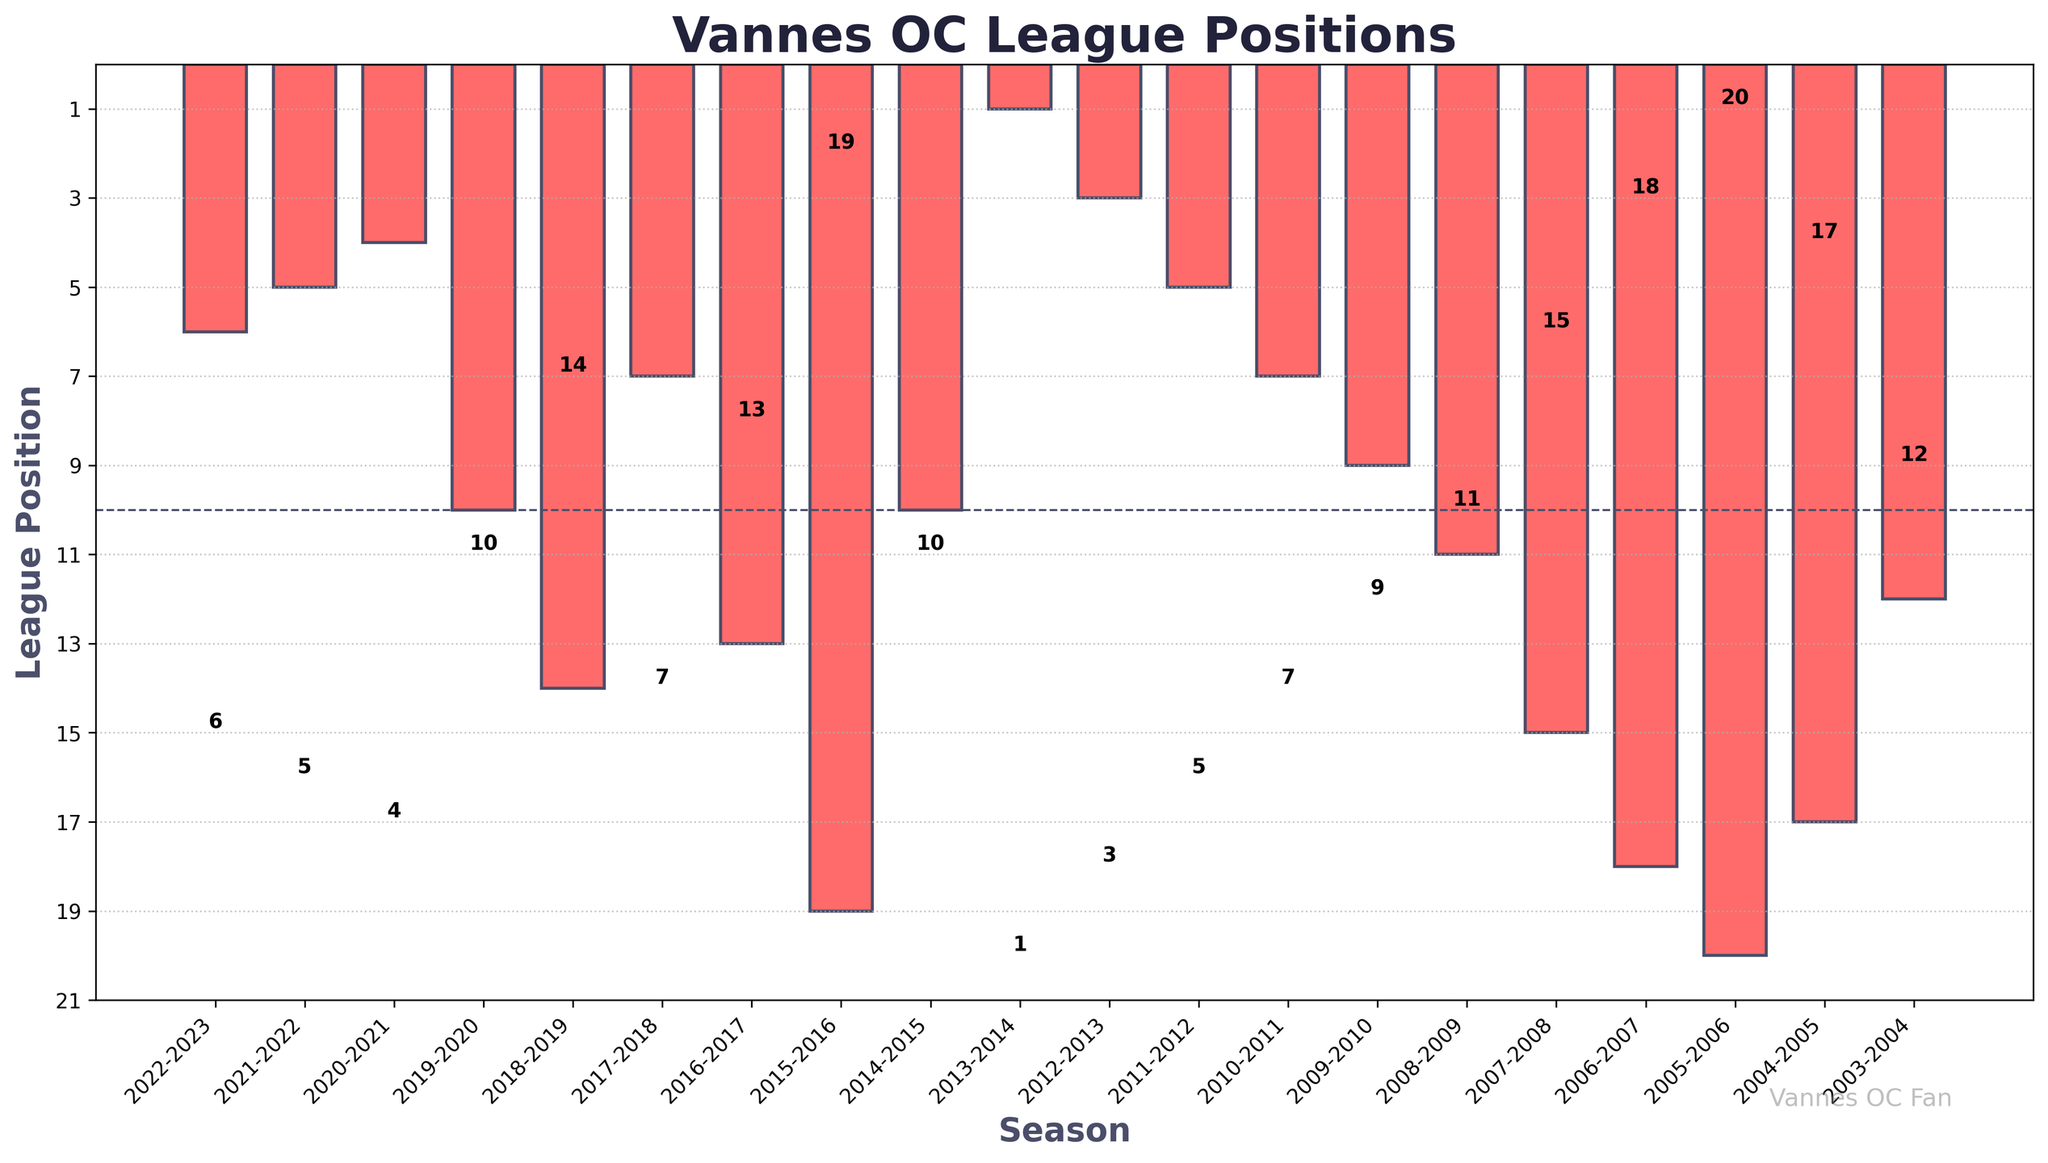Which season did Vannes OC achieve their highest league position? Look at the bar with the shortest height, which represents the highest league position (position 1). This corresponds to the 2013-2014 season.
Answer: 2013-2014 What is the average league position for the seasons from 2018-2019 to 2022-2023? Select the relevant seasons (2018-2019, 2019-2020, 2020-2021, 2021-2022, 2022-2023). Their positions are 14, 10, 4, 5, and 6 respectively. Sum these values: 14 + 10 + 4 + 5 + 6 = 39. Divide by the number of seasons (5): 39/5 = 7.8
Answer: 7.8 How many seasons did Vannes OC finish in the top 5 positions? Identify the bars with heights 1 to 5 (positions 1 to 5). This includes the seasons 2013-2014, 2012-2013, 2020-2021, 2021-2022, and 2022-2023. Count the number of such bars, which is 5.
Answer: 5 In which seasons did Vannes OC finish in a bottom 5 position? Look at the bars representing positions 16 to 20. They correspond to 2004-2005 (17), 2006-2007 (18), 2005-2006 (20), 2015-2016 (19).
Answer: 2004-2005, 2006-2007, 2005-2006, 2015-2016 Which season showed the largest improvement in league position compared to the previous season? Calculate the changes in positions for consecutive seasons and find the largest positive difference. The biggest improvement is between 2015-2016 (19) and 2016-2017 (13), showing a change of 19 - 13 = 6 positions.
Answer: 2016-2017 What is the median league position of Vannes OC in the provided seasons? Arrange the league positions in ascending order: 1, 3, 4, 5, 5, 6, 7, 7, 9, 10, 10, 11, 12, 13, 14, 15, 17, 18, 19, 20. Since there are 20 values, the median will be the average of the 10th and 11th values: (10 + 10) / 2 = 10
Answer: 10 Which season saw Vannes OC fall to their lowest league position? The tallest bar corresponds to the lowest league position (position 20). This is in the 2005-2006 season.
Answer: 2005-2006 In how many seasons did Vannes OC finish above position 10? Count the bars that are shorter than or equal to height 10 (positions 1 to 10). There are 11 such bars for the seasons: 2013-2014, 2012-2013, 2020-2021, 2021-2022, 2022-2023, 2017-2018, 2011-2012, 2010-2011, 2009-2010, 2014-2015, 2019-2020.
Answer: 11 Which years did Vannes OC finish in the same league position? Look for identical bar heights. Vannes OC finished in position 10 during 2014-2015 and 2019-2020, position 7 in 2010-2011 and 2017-2018, and position 5 in 2011-2012 and 2021-2022.
Answer: 2014-2015 & 2019-2020, 2010-2011 & 2017-2018, 2011-2012 & 2021-2022 